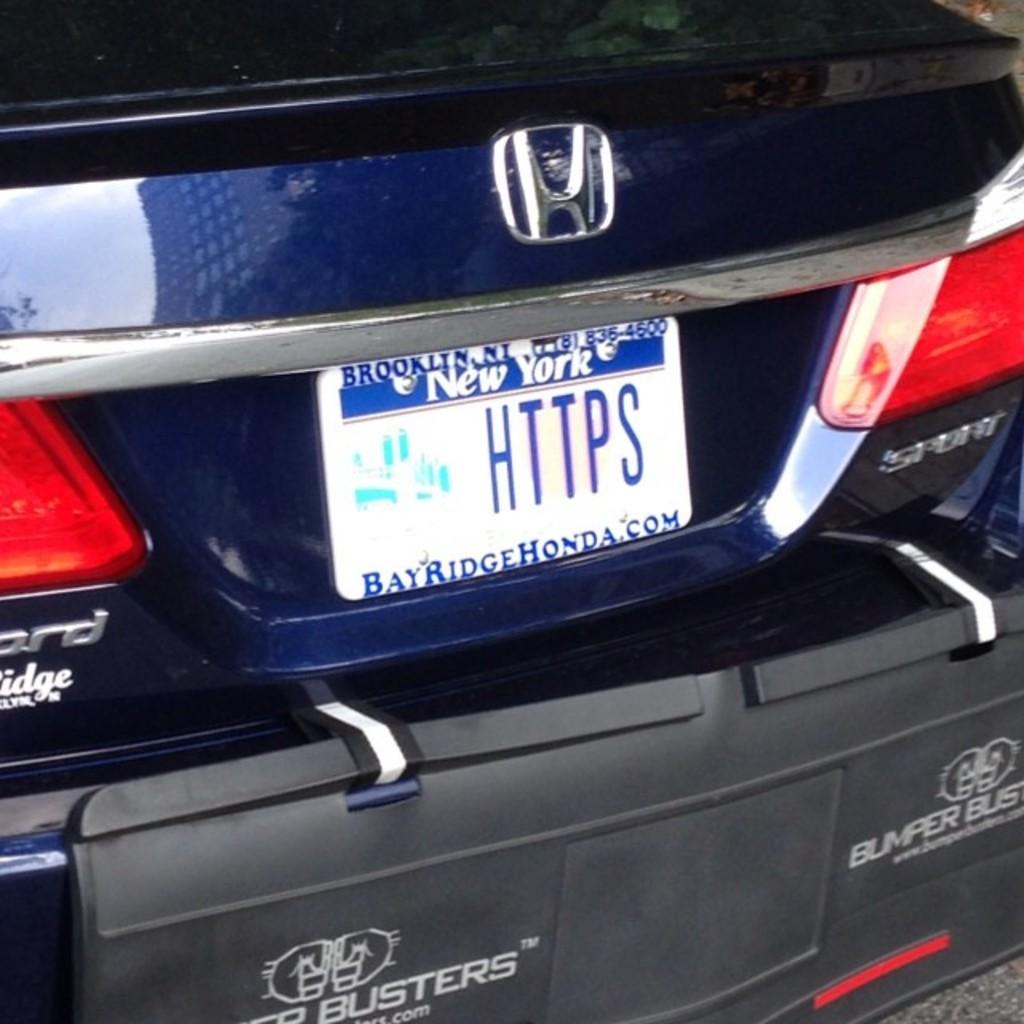What is the license plate number?
Your response must be concise. Https. 